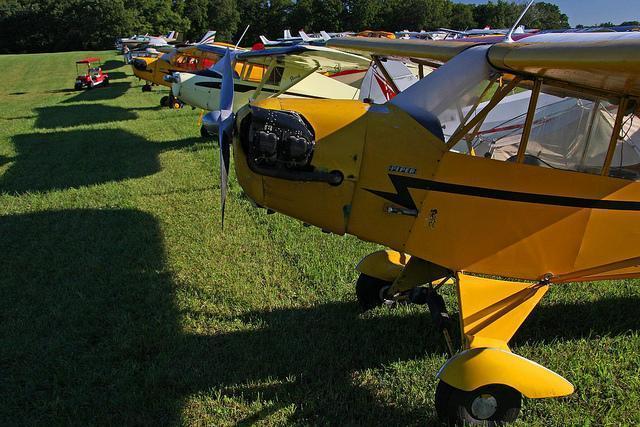How many planes are there?
Give a very brief answer. 5. How many airplanes can be seen?
Give a very brief answer. 3. 